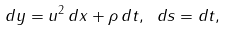<formula> <loc_0><loc_0><loc_500><loc_500>d y = u ^ { 2 } \, d x + \rho \, d t , \ d s = d t ,</formula> 